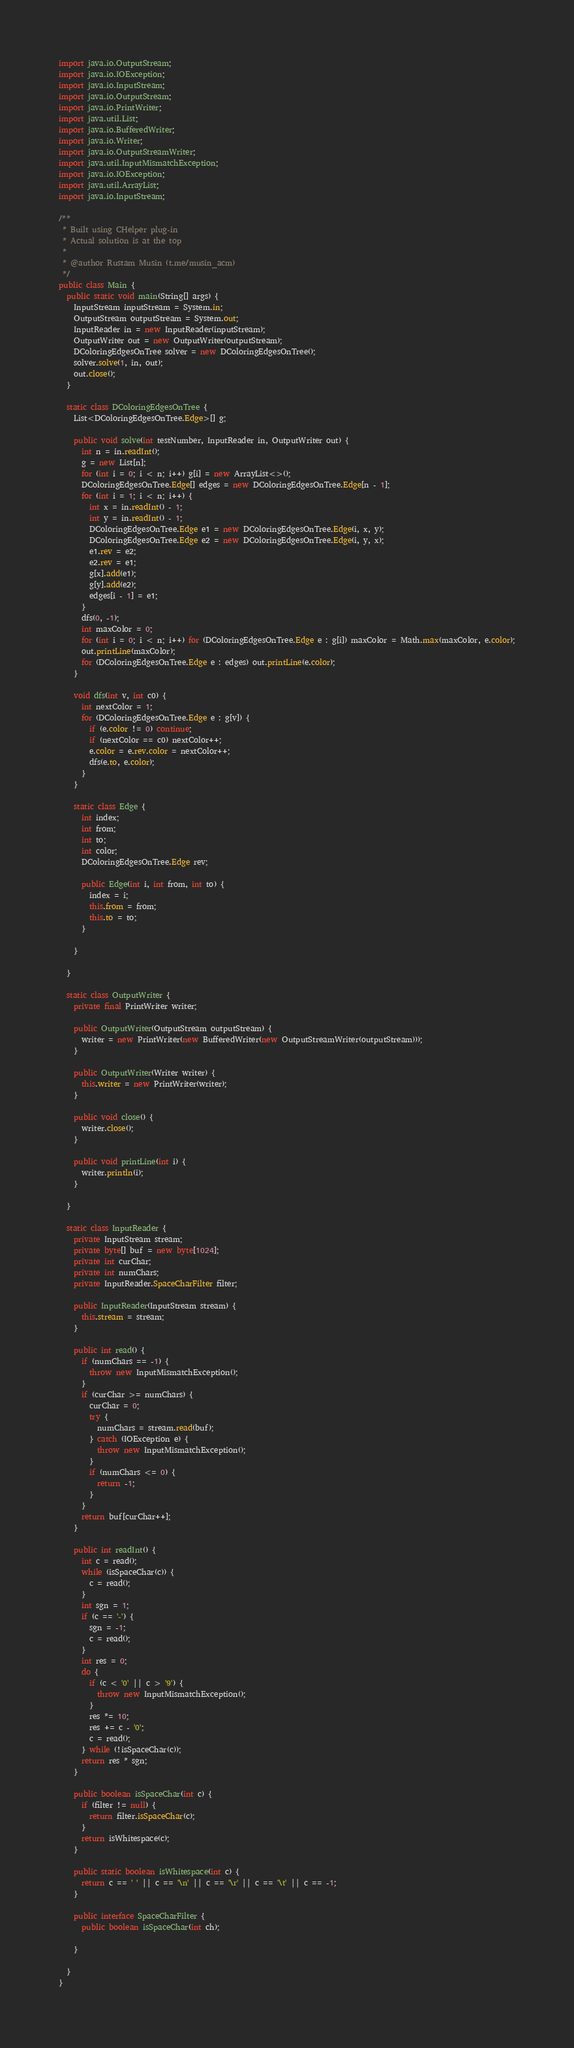Convert code to text. <code><loc_0><loc_0><loc_500><loc_500><_Java_>import java.io.OutputStream;
import java.io.IOException;
import java.io.InputStream;
import java.io.OutputStream;
import java.io.PrintWriter;
import java.util.List;
import java.io.BufferedWriter;
import java.io.Writer;
import java.io.OutputStreamWriter;
import java.util.InputMismatchException;
import java.io.IOException;
import java.util.ArrayList;
import java.io.InputStream;

/**
 * Built using CHelper plug-in
 * Actual solution is at the top
 *
 * @author Rustam Musin (t.me/musin_acm)
 */
public class Main {
  public static void main(String[] args) {
    InputStream inputStream = System.in;
    OutputStream outputStream = System.out;
    InputReader in = new InputReader(inputStream);
    OutputWriter out = new OutputWriter(outputStream);
    DColoringEdgesOnTree solver = new DColoringEdgesOnTree();
    solver.solve(1, in, out);
    out.close();
  }

  static class DColoringEdgesOnTree {
    List<DColoringEdgesOnTree.Edge>[] g;

    public void solve(int testNumber, InputReader in, OutputWriter out) {
      int n = in.readInt();
      g = new List[n];
      for (int i = 0; i < n; i++) g[i] = new ArrayList<>();
      DColoringEdgesOnTree.Edge[] edges = new DColoringEdgesOnTree.Edge[n - 1];
      for (int i = 1; i < n; i++) {
        int x = in.readInt() - 1;
        int y = in.readInt() - 1;
        DColoringEdgesOnTree.Edge e1 = new DColoringEdgesOnTree.Edge(i, x, y);
        DColoringEdgesOnTree.Edge e2 = new DColoringEdgesOnTree.Edge(i, y, x);
        e1.rev = e2;
        e2.rev = e1;
        g[x].add(e1);
        g[y].add(e2);
        edges[i - 1] = e1;
      }
      dfs(0, -1);
      int maxColor = 0;
      for (int i = 0; i < n; i++) for (DColoringEdgesOnTree.Edge e : g[i]) maxColor = Math.max(maxColor, e.color);
      out.printLine(maxColor);
      for (DColoringEdgesOnTree.Edge e : edges) out.printLine(e.color);
    }

    void dfs(int v, int c0) {
      int nextColor = 1;
      for (DColoringEdgesOnTree.Edge e : g[v]) {
        if (e.color != 0) continue;
        if (nextColor == c0) nextColor++;
        e.color = e.rev.color = nextColor++;
        dfs(e.to, e.color);
      }
    }

    static class Edge {
      int index;
      int from;
      int to;
      int color;
      DColoringEdgesOnTree.Edge rev;

      public Edge(int i, int from, int to) {
        index = i;
        this.from = from;
        this.to = to;
      }

    }

  }

  static class OutputWriter {
    private final PrintWriter writer;

    public OutputWriter(OutputStream outputStream) {
      writer = new PrintWriter(new BufferedWriter(new OutputStreamWriter(outputStream)));
    }

    public OutputWriter(Writer writer) {
      this.writer = new PrintWriter(writer);
    }

    public void close() {
      writer.close();
    }

    public void printLine(int i) {
      writer.println(i);
    }

  }

  static class InputReader {
    private InputStream stream;
    private byte[] buf = new byte[1024];
    private int curChar;
    private int numChars;
    private InputReader.SpaceCharFilter filter;

    public InputReader(InputStream stream) {
      this.stream = stream;
    }

    public int read() {
      if (numChars == -1) {
        throw new InputMismatchException();
      }
      if (curChar >= numChars) {
        curChar = 0;
        try {
          numChars = stream.read(buf);
        } catch (IOException e) {
          throw new InputMismatchException();
        }
        if (numChars <= 0) {
          return -1;
        }
      }
      return buf[curChar++];
    }

    public int readInt() {
      int c = read();
      while (isSpaceChar(c)) {
        c = read();
      }
      int sgn = 1;
      if (c == '-') {
        sgn = -1;
        c = read();
      }
      int res = 0;
      do {
        if (c < '0' || c > '9') {
          throw new InputMismatchException();
        }
        res *= 10;
        res += c - '0';
        c = read();
      } while (!isSpaceChar(c));
      return res * sgn;
    }

    public boolean isSpaceChar(int c) {
      if (filter != null) {
        return filter.isSpaceChar(c);
      }
      return isWhitespace(c);
    }

    public static boolean isWhitespace(int c) {
      return c == ' ' || c == '\n' || c == '\r' || c == '\t' || c == -1;
    }

    public interface SpaceCharFilter {
      public boolean isSpaceChar(int ch);

    }

  }
}

</code> 